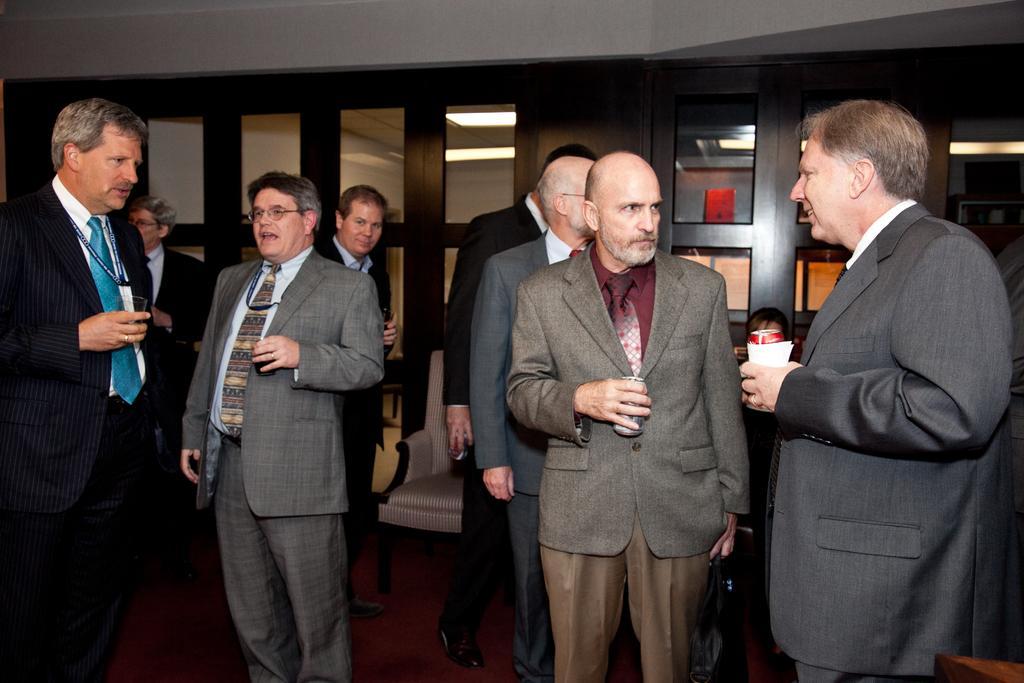Describe this image in one or two sentences. In this picture, we see a group of people are standing. The man on the right side who is wearing the black blazer is holding the coke bottle and the tissue paper. Beside him, we see a man is holding a coke bottle. The man on the left side who is wearing the blazer is holding a glass in his hands. In the background, we see the glass windows and doors. At the top, we see the roof of the building. 